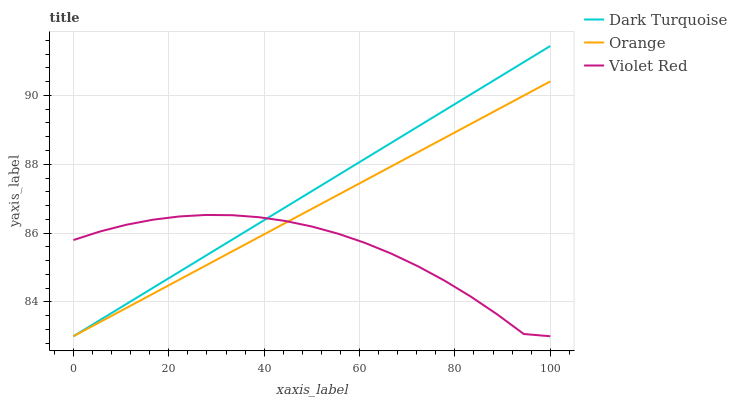Does Violet Red have the minimum area under the curve?
Answer yes or no. Yes. Does Dark Turquoise have the maximum area under the curve?
Answer yes or no. Yes. Does Dark Turquoise have the minimum area under the curve?
Answer yes or no. No. Does Violet Red have the maximum area under the curve?
Answer yes or no. No. Is Orange the smoothest?
Answer yes or no. Yes. Is Violet Red the roughest?
Answer yes or no. Yes. Is Dark Turquoise the smoothest?
Answer yes or no. No. Is Dark Turquoise the roughest?
Answer yes or no. No. Does Orange have the lowest value?
Answer yes or no. Yes. Does Dark Turquoise have the highest value?
Answer yes or no. Yes. Does Violet Red have the highest value?
Answer yes or no. No. Does Orange intersect Dark Turquoise?
Answer yes or no. Yes. Is Orange less than Dark Turquoise?
Answer yes or no. No. Is Orange greater than Dark Turquoise?
Answer yes or no. No. 